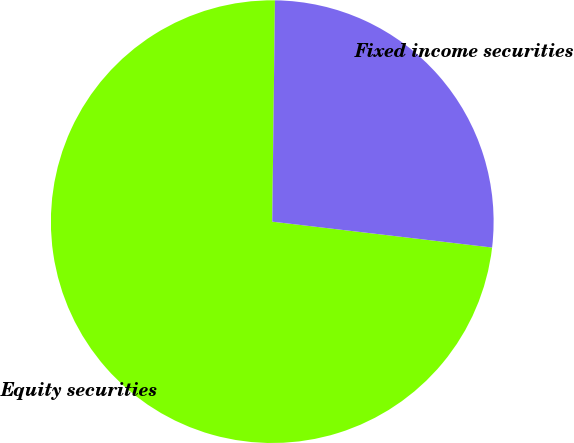Convert chart to OTSL. <chart><loc_0><loc_0><loc_500><loc_500><pie_chart><fcel>Equity securities<fcel>Fixed income securities<nl><fcel>73.33%<fcel>26.67%<nl></chart> 